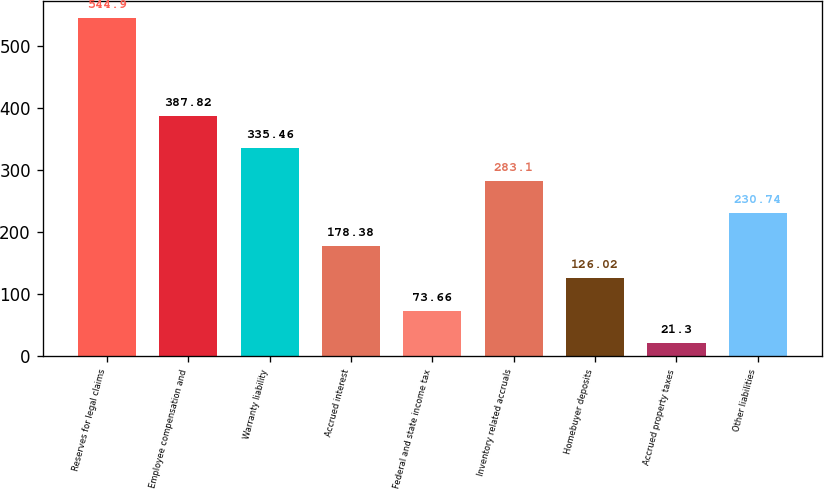Convert chart to OTSL. <chart><loc_0><loc_0><loc_500><loc_500><bar_chart><fcel>Reserves for legal claims<fcel>Employee compensation and<fcel>Warranty liability<fcel>Accrued interest<fcel>Federal and state income tax<fcel>Inventory related accruals<fcel>Homebuyer deposits<fcel>Accrued property taxes<fcel>Other liabilities<nl><fcel>544.9<fcel>387.82<fcel>335.46<fcel>178.38<fcel>73.66<fcel>283.1<fcel>126.02<fcel>21.3<fcel>230.74<nl></chart> 